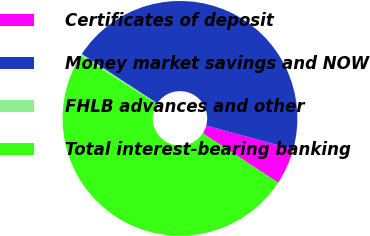<chart> <loc_0><loc_0><loc_500><loc_500><pie_chart><fcel>Certificates of deposit<fcel>Money market savings and NOW<fcel>FHLB advances and other<fcel>Total interest-bearing banking<nl><fcel>4.98%<fcel>45.02%<fcel>0.3%<fcel>49.7%<nl></chart> 